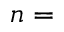Convert formula to latex. <formula><loc_0><loc_0><loc_500><loc_500>n =</formula> 